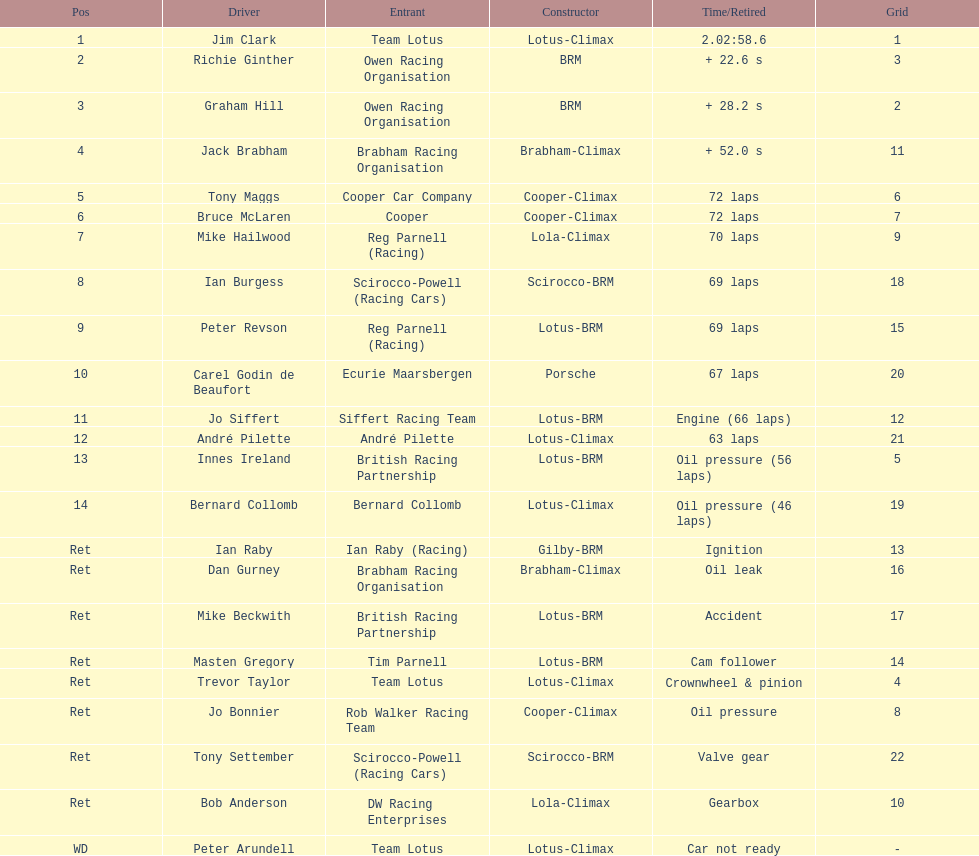Help me parse the entirety of this table. {'header': ['Pos', 'Driver', 'Entrant', 'Constructor', 'Time/Retired', 'Grid'], 'rows': [['1', 'Jim Clark', 'Team Lotus', 'Lotus-Climax', '2.02:58.6', '1'], ['2', 'Richie Ginther', 'Owen Racing Organisation', 'BRM', '+ 22.6 s', '3'], ['3', 'Graham Hill', 'Owen Racing Organisation', 'BRM', '+ 28.2 s', '2'], ['4', 'Jack Brabham', 'Brabham Racing Organisation', 'Brabham-Climax', '+ 52.0 s', '11'], ['5', 'Tony Maggs', 'Cooper Car Company', 'Cooper-Climax', '72 laps', '6'], ['6', 'Bruce McLaren', 'Cooper', 'Cooper-Climax', '72 laps', '7'], ['7', 'Mike Hailwood', 'Reg Parnell (Racing)', 'Lola-Climax', '70 laps', '9'], ['8', 'Ian Burgess', 'Scirocco-Powell (Racing Cars)', 'Scirocco-BRM', '69 laps', '18'], ['9', 'Peter Revson', 'Reg Parnell (Racing)', 'Lotus-BRM', '69 laps', '15'], ['10', 'Carel Godin de Beaufort', 'Ecurie Maarsbergen', 'Porsche', '67 laps', '20'], ['11', 'Jo Siffert', 'Siffert Racing Team', 'Lotus-BRM', 'Engine (66 laps)', '12'], ['12', 'André Pilette', 'André Pilette', 'Lotus-Climax', '63 laps', '21'], ['13', 'Innes Ireland', 'British Racing Partnership', 'Lotus-BRM', 'Oil pressure (56 laps)', '5'], ['14', 'Bernard Collomb', 'Bernard Collomb', 'Lotus-Climax', 'Oil pressure (46 laps)', '19'], ['Ret', 'Ian Raby', 'Ian Raby (Racing)', 'Gilby-BRM', 'Ignition', '13'], ['Ret', 'Dan Gurney', 'Brabham Racing Organisation', 'Brabham-Climax', 'Oil leak', '16'], ['Ret', 'Mike Beckwith', 'British Racing Partnership', 'Lotus-BRM', 'Accident', '17'], ['Ret', 'Masten Gregory', 'Tim Parnell', 'Lotus-BRM', 'Cam follower', '14'], ['Ret', 'Trevor Taylor', 'Team Lotus', 'Lotus-Climax', 'Crownwheel & pinion', '4'], ['Ret', 'Jo Bonnier', 'Rob Walker Racing Team', 'Cooper-Climax', 'Oil pressure', '8'], ['Ret', 'Tony Settember', 'Scirocco-Powell (Racing Cars)', 'Scirocco-BRM', 'Valve gear', '22'], ['Ret', 'Bob Anderson', 'DW Racing Enterprises', 'Lola-Climax', 'Gearbox', '10'], ['WD', 'Peter Arundell', 'Team Lotus', 'Lotus-Climax', 'Car not ready', '-']]} What is the count of americans in the top 5? 1. 